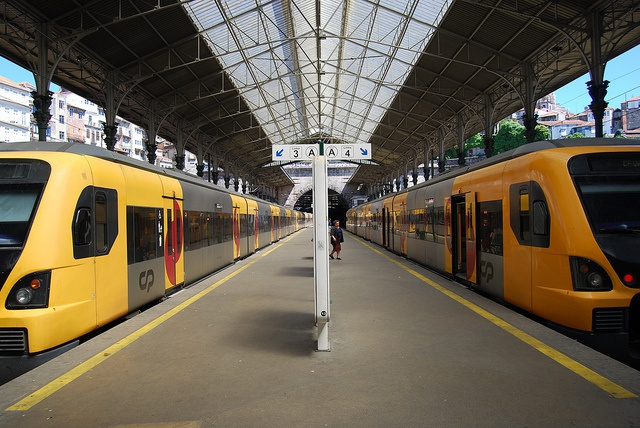Describe the objects in this image and their specific colors. I can see train in black, orange, gold, and gray tones, train in black, brown, and maroon tones, people in black, maroon, and gray tones, and people in black, gray, and darkgray tones in this image. 